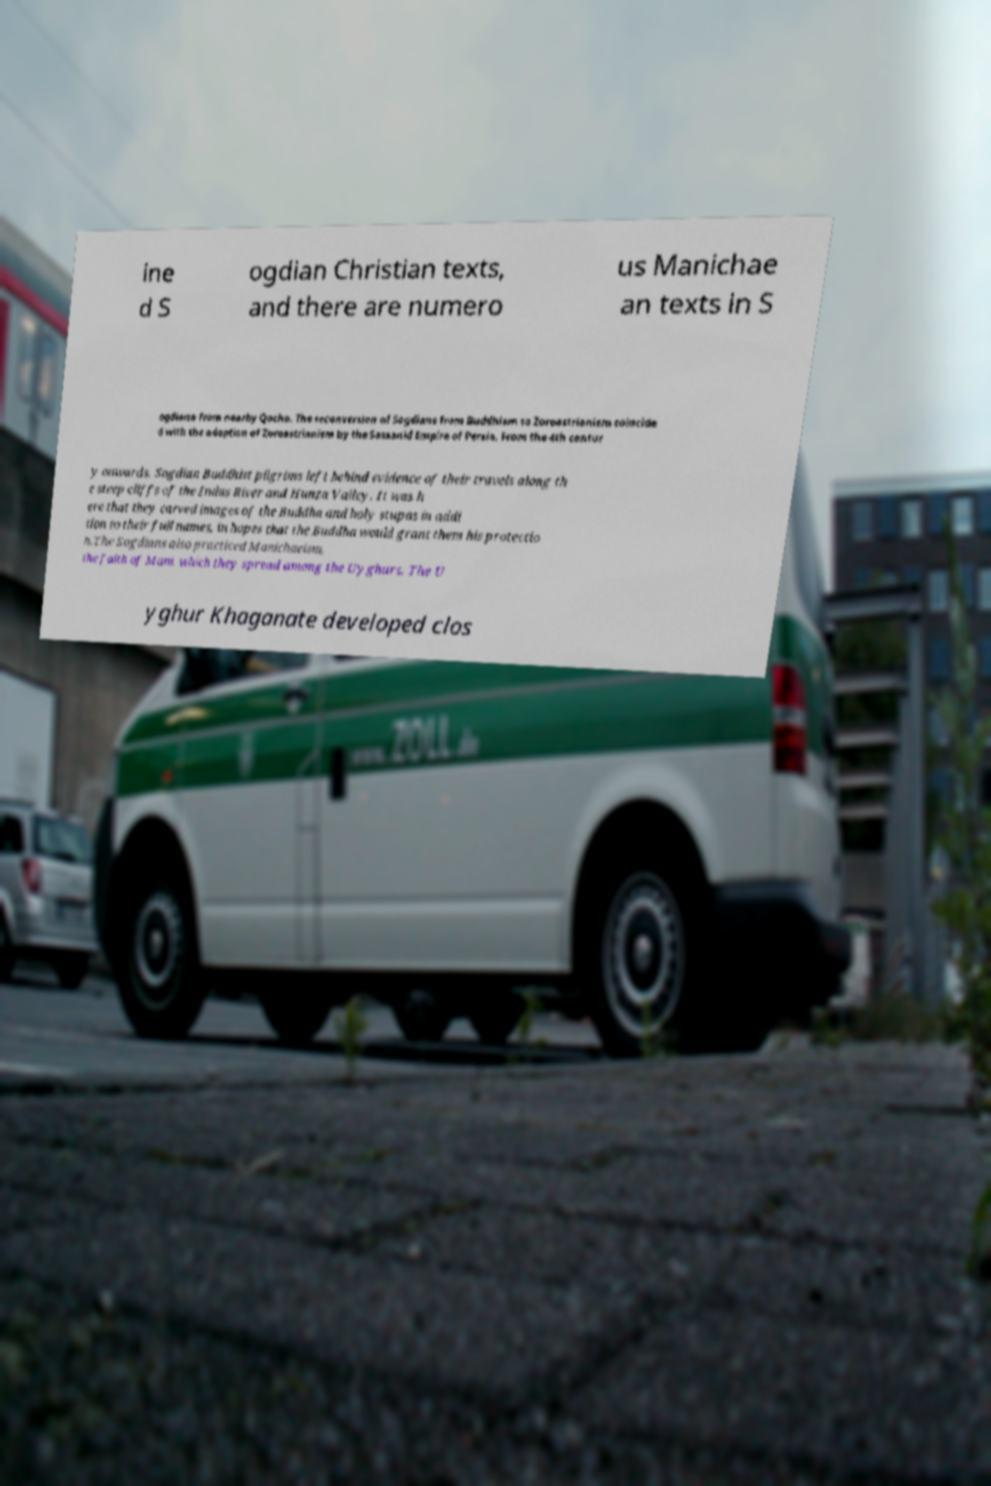Can you accurately transcribe the text from the provided image for me? ine d S ogdian Christian texts, and there are numero us Manichae an texts in S ogdiana from nearby Qocho. The reconversion of Sogdians from Buddhism to Zoroastrianism coincide d with the adoption of Zoroastrianism by the Sassanid Empire of Persia. From the 4th centur y onwards, Sogdian Buddhist pilgrims left behind evidence of their travels along th e steep cliffs of the Indus River and Hunza Valley. It was h ere that they carved images of the Buddha and holy stupas in addi tion to their full names, in hopes that the Buddha would grant them his protectio n.The Sogdians also practiced Manichaeism, the faith of Mani, which they spread among the Uyghurs. The U yghur Khaganate developed clos 